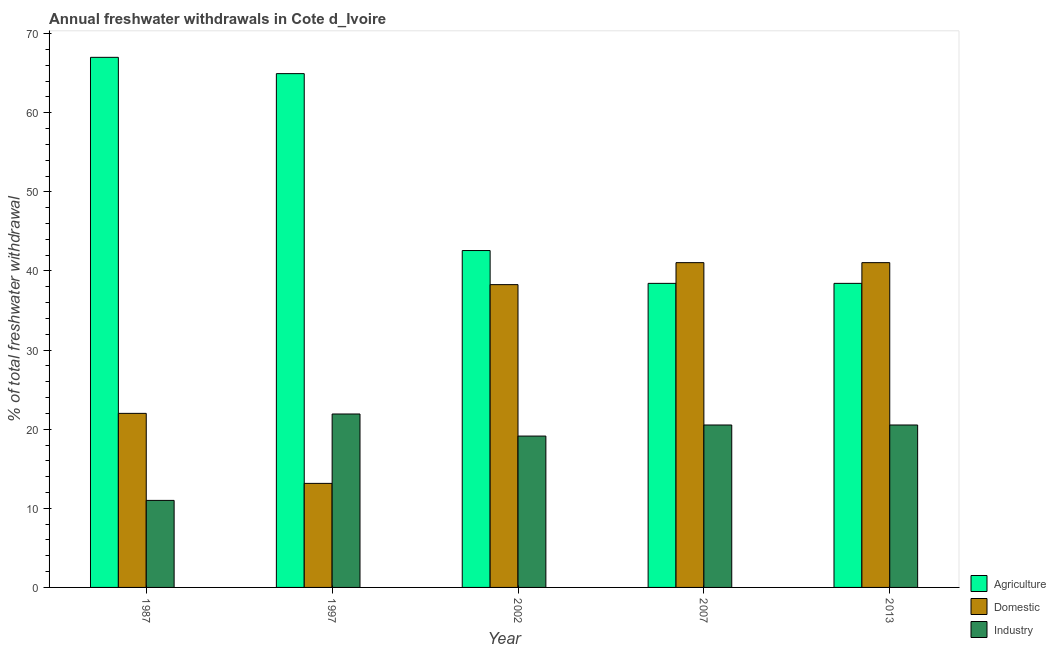How many different coloured bars are there?
Your answer should be compact. 3. Are the number of bars on each tick of the X-axis equal?
Offer a terse response. Yes. In how many cases, is the number of bars for a given year not equal to the number of legend labels?
Your response must be concise. 0. What is the percentage of freshwater withdrawal for agriculture in 1987?
Make the answer very short. 67. Across all years, what is the maximum percentage of freshwater withdrawal for domestic purposes?
Give a very brief answer. 41.05. Across all years, what is the minimum percentage of freshwater withdrawal for industry?
Your response must be concise. 11. In which year was the percentage of freshwater withdrawal for domestic purposes minimum?
Give a very brief answer. 1997. What is the total percentage of freshwater withdrawal for industry in the graph?
Provide a short and direct response. 93.11. What is the difference between the percentage of freshwater withdrawal for domestic purposes in 1997 and that in 2002?
Your response must be concise. -25.12. What is the difference between the percentage of freshwater withdrawal for domestic purposes in 2013 and the percentage of freshwater withdrawal for industry in 1997?
Your answer should be very brief. 27.9. What is the average percentage of freshwater withdrawal for industry per year?
Offer a very short reply. 18.62. In the year 2013, what is the difference between the percentage of freshwater withdrawal for agriculture and percentage of freshwater withdrawal for industry?
Provide a succinct answer. 0. In how many years, is the percentage of freshwater withdrawal for domestic purposes greater than 36 %?
Your answer should be compact. 3. What is the ratio of the percentage of freshwater withdrawal for industry in 1987 to that in 2013?
Keep it short and to the point. 0.54. What is the difference between the highest and the second highest percentage of freshwater withdrawal for agriculture?
Offer a very short reply. 2.06. What is the difference between the highest and the lowest percentage of freshwater withdrawal for domestic purposes?
Your answer should be very brief. 27.9. What does the 3rd bar from the left in 1997 represents?
Provide a succinct answer. Industry. What does the 2nd bar from the right in 1997 represents?
Ensure brevity in your answer.  Domestic. Is it the case that in every year, the sum of the percentage of freshwater withdrawal for agriculture and percentage of freshwater withdrawal for domestic purposes is greater than the percentage of freshwater withdrawal for industry?
Offer a very short reply. Yes. How many bars are there?
Your response must be concise. 15. Does the graph contain grids?
Make the answer very short. No. How many legend labels are there?
Offer a very short reply. 3. How are the legend labels stacked?
Provide a short and direct response. Vertical. What is the title of the graph?
Offer a terse response. Annual freshwater withdrawals in Cote d_Ivoire. Does "Travel services" appear as one of the legend labels in the graph?
Provide a short and direct response. No. What is the label or title of the X-axis?
Your answer should be compact. Year. What is the label or title of the Y-axis?
Your answer should be very brief. % of total freshwater withdrawal. What is the % of total freshwater withdrawal in Domestic in 1987?
Provide a short and direct response. 22. What is the % of total freshwater withdrawal of Agriculture in 1997?
Your answer should be compact. 64.94. What is the % of total freshwater withdrawal in Domestic in 1997?
Provide a succinct answer. 13.15. What is the % of total freshwater withdrawal in Industry in 1997?
Provide a short and direct response. 21.92. What is the % of total freshwater withdrawal in Agriculture in 2002?
Provide a short and direct response. 42.58. What is the % of total freshwater withdrawal in Domestic in 2002?
Keep it short and to the point. 38.27. What is the % of total freshwater withdrawal in Industry in 2002?
Your answer should be compact. 19.13. What is the % of total freshwater withdrawal of Agriculture in 2007?
Offer a very short reply. 38.43. What is the % of total freshwater withdrawal of Domestic in 2007?
Offer a terse response. 41.05. What is the % of total freshwater withdrawal of Industry in 2007?
Offer a very short reply. 20.53. What is the % of total freshwater withdrawal in Agriculture in 2013?
Offer a very short reply. 38.43. What is the % of total freshwater withdrawal of Domestic in 2013?
Offer a terse response. 41.05. What is the % of total freshwater withdrawal of Industry in 2013?
Make the answer very short. 20.53. Across all years, what is the maximum % of total freshwater withdrawal in Domestic?
Offer a very short reply. 41.05. Across all years, what is the maximum % of total freshwater withdrawal in Industry?
Ensure brevity in your answer.  21.92. Across all years, what is the minimum % of total freshwater withdrawal in Agriculture?
Give a very brief answer. 38.43. Across all years, what is the minimum % of total freshwater withdrawal in Domestic?
Make the answer very short. 13.15. What is the total % of total freshwater withdrawal of Agriculture in the graph?
Offer a terse response. 251.38. What is the total % of total freshwater withdrawal of Domestic in the graph?
Make the answer very short. 155.52. What is the total % of total freshwater withdrawal in Industry in the graph?
Make the answer very short. 93.11. What is the difference between the % of total freshwater withdrawal of Agriculture in 1987 and that in 1997?
Keep it short and to the point. 2.06. What is the difference between the % of total freshwater withdrawal in Domestic in 1987 and that in 1997?
Your response must be concise. 8.85. What is the difference between the % of total freshwater withdrawal in Industry in 1987 and that in 1997?
Your answer should be very brief. -10.92. What is the difference between the % of total freshwater withdrawal of Agriculture in 1987 and that in 2002?
Offer a terse response. 24.42. What is the difference between the % of total freshwater withdrawal in Domestic in 1987 and that in 2002?
Offer a very short reply. -16.27. What is the difference between the % of total freshwater withdrawal in Industry in 1987 and that in 2002?
Provide a succinct answer. -8.13. What is the difference between the % of total freshwater withdrawal of Agriculture in 1987 and that in 2007?
Ensure brevity in your answer.  28.57. What is the difference between the % of total freshwater withdrawal in Domestic in 1987 and that in 2007?
Your answer should be very brief. -19.05. What is the difference between the % of total freshwater withdrawal of Industry in 1987 and that in 2007?
Your answer should be very brief. -9.53. What is the difference between the % of total freshwater withdrawal of Agriculture in 1987 and that in 2013?
Offer a terse response. 28.57. What is the difference between the % of total freshwater withdrawal of Domestic in 1987 and that in 2013?
Make the answer very short. -19.05. What is the difference between the % of total freshwater withdrawal in Industry in 1987 and that in 2013?
Provide a succinct answer. -9.53. What is the difference between the % of total freshwater withdrawal of Agriculture in 1997 and that in 2002?
Your response must be concise. 22.36. What is the difference between the % of total freshwater withdrawal of Domestic in 1997 and that in 2002?
Keep it short and to the point. -25.12. What is the difference between the % of total freshwater withdrawal of Industry in 1997 and that in 2002?
Ensure brevity in your answer.  2.79. What is the difference between the % of total freshwater withdrawal in Agriculture in 1997 and that in 2007?
Make the answer very short. 26.51. What is the difference between the % of total freshwater withdrawal in Domestic in 1997 and that in 2007?
Offer a terse response. -27.9. What is the difference between the % of total freshwater withdrawal in Industry in 1997 and that in 2007?
Keep it short and to the point. 1.39. What is the difference between the % of total freshwater withdrawal of Agriculture in 1997 and that in 2013?
Provide a succinct answer. 26.51. What is the difference between the % of total freshwater withdrawal in Domestic in 1997 and that in 2013?
Provide a short and direct response. -27.9. What is the difference between the % of total freshwater withdrawal of Industry in 1997 and that in 2013?
Give a very brief answer. 1.39. What is the difference between the % of total freshwater withdrawal of Agriculture in 2002 and that in 2007?
Provide a succinct answer. 4.15. What is the difference between the % of total freshwater withdrawal of Domestic in 2002 and that in 2007?
Offer a terse response. -2.78. What is the difference between the % of total freshwater withdrawal in Industry in 2002 and that in 2007?
Offer a very short reply. -1.4. What is the difference between the % of total freshwater withdrawal of Agriculture in 2002 and that in 2013?
Ensure brevity in your answer.  4.15. What is the difference between the % of total freshwater withdrawal in Domestic in 2002 and that in 2013?
Ensure brevity in your answer.  -2.78. What is the difference between the % of total freshwater withdrawal of Agriculture in 2007 and that in 2013?
Your response must be concise. 0. What is the difference between the % of total freshwater withdrawal in Agriculture in 1987 and the % of total freshwater withdrawal in Domestic in 1997?
Give a very brief answer. 53.85. What is the difference between the % of total freshwater withdrawal of Agriculture in 1987 and the % of total freshwater withdrawal of Industry in 1997?
Provide a succinct answer. 45.08. What is the difference between the % of total freshwater withdrawal in Domestic in 1987 and the % of total freshwater withdrawal in Industry in 1997?
Provide a succinct answer. 0.08. What is the difference between the % of total freshwater withdrawal in Agriculture in 1987 and the % of total freshwater withdrawal in Domestic in 2002?
Your response must be concise. 28.73. What is the difference between the % of total freshwater withdrawal of Agriculture in 1987 and the % of total freshwater withdrawal of Industry in 2002?
Your answer should be very brief. 47.87. What is the difference between the % of total freshwater withdrawal in Domestic in 1987 and the % of total freshwater withdrawal in Industry in 2002?
Offer a terse response. 2.87. What is the difference between the % of total freshwater withdrawal in Agriculture in 1987 and the % of total freshwater withdrawal in Domestic in 2007?
Your answer should be compact. 25.95. What is the difference between the % of total freshwater withdrawal in Agriculture in 1987 and the % of total freshwater withdrawal in Industry in 2007?
Ensure brevity in your answer.  46.47. What is the difference between the % of total freshwater withdrawal of Domestic in 1987 and the % of total freshwater withdrawal of Industry in 2007?
Offer a very short reply. 1.47. What is the difference between the % of total freshwater withdrawal in Agriculture in 1987 and the % of total freshwater withdrawal in Domestic in 2013?
Provide a succinct answer. 25.95. What is the difference between the % of total freshwater withdrawal in Agriculture in 1987 and the % of total freshwater withdrawal in Industry in 2013?
Offer a very short reply. 46.47. What is the difference between the % of total freshwater withdrawal in Domestic in 1987 and the % of total freshwater withdrawal in Industry in 2013?
Keep it short and to the point. 1.47. What is the difference between the % of total freshwater withdrawal in Agriculture in 1997 and the % of total freshwater withdrawal in Domestic in 2002?
Your response must be concise. 26.67. What is the difference between the % of total freshwater withdrawal of Agriculture in 1997 and the % of total freshwater withdrawal of Industry in 2002?
Provide a short and direct response. 45.81. What is the difference between the % of total freshwater withdrawal in Domestic in 1997 and the % of total freshwater withdrawal in Industry in 2002?
Your answer should be very brief. -5.98. What is the difference between the % of total freshwater withdrawal of Agriculture in 1997 and the % of total freshwater withdrawal of Domestic in 2007?
Your response must be concise. 23.89. What is the difference between the % of total freshwater withdrawal of Agriculture in 1997 and the % of total freshwater withdrawal of Industry in 2007?
Your answer should be compact. 44.41. What is the difference between the % of total freshwater withdrawal of Domestic in 1997 and the % of total freshwater withdrawal of Industry in 2007?
Ensure brevity in your answer.  -7.38. What is the difference between the % of total freshwater withdrawal in Agriculture in 1997 and the % of total freshwater withdrawal in Domestic in 2013?
Offer a terse response. 23.89. What is the difference between the % of total freshwater withdrawal of Agriculture in 1997 and the % of total freshwater withdrawal of Industry in 2013?
Your answer should be compact. 44.41. What is the difference between the % of total freshwater withdrawal of Domestic in 1997 and the % of total freshwater withdrawal of Industry in 2013?
Your response must be concise. -7.38. What is the difference between the % of total freshwater withdrawal of Agriculture in 2002 and the % of total freshwater withdrawal of Domestic in 2007?
Offer a terse response. 1.53. What is the difference between the % of total freshwater withdrawal in Agriculture in 2002 and the % of total freshwater withdrawal in Industry in 2007?
Make the answer very short. 22.05. What is the difference between the % of total freshwater withdrawal in Domestic in 2002 and the % of total freshwater withdrawal in Industry in 2007?
Your answer should be very brief. 17.74. What is the difference between the % of total freshwater withdrawal of Agriculture in 2002 and the % of total freshwater withdrawal of Domestic in 2013?
Offer a very short reply. 1.53. What is the difference between the % of total freshwater withdrawal of Agriculture in 2002 and the % of total freshwater withdrawal of Industry in 2013?
Ensure brevity in your answer.  22.05. What is the difference between the % of total freshwater withdrawal of Domestic in 2002 and the % of total freshwater withdrawal of Industry in 2013?
Your response must be concise. 17.74. What is the difference between the % of total freshwater withdrawal of Agriculture in 2007 and the % of total freshwater withdrawal of Domestic in 2013?
Your answer should be very brief. -2.62. What is the difference between the % of total freshwater withdrawal in Domestic in 2007 and the % of total freshwater withdrawal in Industry in 2013?
Your answer should be compact. 20.52. What is the average % of total freshwater withdrawal in Agriculture per year?
Your answer should be compact. 50.28. What is the average % of total freshwater withdrawal of Domestic per year?
Give a very brief answer. 31.1. What is the average % of total freshwater withdrawal of Industry per year?
Give a very brief answer. 18.62. In the year 1987, what is the difference between the % of total freshwater withdrawal of Agriculture and % of total freshwater withdrawal of Domestic?
Your answer should be compact. 45. In the year 1987, what is the difference between the % of total freshwater withdrawal in Agriculture and % of total freshwater withdrawal in Industry?
Your answer should be compact. 56. In the year 1987, what is the difference between the % of total freshwater withdrawal in Domestic and % of total freshwater withdrawal in Industry?
Provide a short and direct response. 11. In the year 1997, what is the difference between the % of total freshwater withdrawal in Agriculture and % of total freshwater withdrawal in Domestic?
Your answer should be very brief. 51.79. In the year 1997, what is the difference between the % of total freshwater withdrawal in Agriculture and % of total freshwater withdrawal in Industry?
Offer a very short reply. 43.02. In the year 1997, what is the difference between the % of total freshwater withdrawal of Domestic and % of total freshwater withdrawal of Industry?
Keep it short and to the point. -8.77. In the year 2002, what is the difference between the % of total freshwater withdrawal in Agriculture and % of total freshwater withdrawal in Domestic?
Provide a short and direct response. 4.31. In the year 2002, what is the difference between the % of total freshwater withdrawal in Agriculture and % of total freshwater withdrawal in Industry?
Your response must be concise. 23.45. In the year 2002, what is the difference between the % of total freshwater withdrawal in Domestic and % of total freshwater withdrawal in Industry?
Provide a short and direct response. 19.14. In the year 2007, what is the difference between the % of total freshwater withdrawal of Agriculture and % of total freshwater withdrawal of Domestic?
Give a very brief answer. -2.62. In the year 2007, what is the difference between the % of total freshwater withdrawal of Domestic and % of total freshwater withdrawal of Industry?
Make the answer very short. 20.52. In the year 2013, what is the difference between the % of total freshwater withdrawal in Agriculture and % of total freshwater withdrawal in Domestic?
Offer a very short reply. -2.62. In the year 2013, what is the difference between the % of total freshwater withdrawal in Domestic and % of total freshwater withdrawal in Industry?
Give a very brief answer. 20.52. What is the ratio of the % of total freshwater withdrawal of Agriculture in 1987 to that in 1997?
Your answer should be compact. 1.03. What is the ratio of the % of total freshwater withdrawal of Domestic in 1987 to that in 1997?
Your answer should be compact. 1.67. What is the ratio of the % of total freshwater withdrawal in Industry in 1987 to that in 1997?
Your answer should be compact. 0.5. What is the ratio of the % of total freshwater withdrawal in Agriculture in 1987 to that in 2002?
Provide a short and direct response. 1.57. What is the ratio of the % of total freshwater withdrawal in Domestic in 1987 to that in 2002?
Offer a terse response. 0.57. What is the ratio of the % of total freshwater withdrawal in Industry in 1987 to that in 2002?
Give a very brief answer. 0.57. What is the ratio of the % of total freshwater withdrawal of Agriculture in 1987 to that in 2007?
Provide a short and direct response. 1.74. What is the ratio of the % of total freshwater withdrawal in Domestic in 1987 to that in 2007?
Your response must be concise. 0.54. What is the ratio of the % of total freshwater withdrawal of Industry in 1987 to that in 2007?
Make the answer very short. 0.54. What is the ratio of the % of total freshwater withdrawal in Agriculture in 1987 to that in 2013?
Your answer should be compact. 1.74. What is the ratio of the % of total freshwater withdrawal in Domestic in 1987 to that in 2013?
Your answer should be compact. 0.54. What is the ratio of the % of total freshwater withdrawal in Industry in 1987 to that in 2013?
Your response must be concise. 0.54. What is the ratio of the % of total freshwater withdrawal of Agriculture in 1997 to that in 2002?
Keep it short and to the point. 1.53. What is the ratio of the % of total freshwater withdrawal of Domestic in 1997 to that in 2002?
Your answer should be very brief. 0.34. What is the ratio of the % of total freshwater withdrawal of Industry in 1997 to that in 2002?
Give a very brief answer. 1.15. What is the ratio of the % of total freshwater withdrawal in Agriculture in 1997 to that in 2007?
Offer a very short reply. 1.69. What is the ratio of the % of total freshwater withdrawal in Domestic in 1997 to that in 2007?
Provide a succinct answer. 0.32. What is the ratio of the % of total freshwater withdrawal in Industry in 1997 to that in 2007?
Your answer should be compact. 1.07. What is the ratio of the % of total freshwater withdrawal in Agriculture in 1997 to that in 2013?
Provide a succinct answer. 1.69. What is the ratio of the % of total freshwater withdrawal of Domestic in 1997 to that in 2013?
Your answer should be very brief. 0.32. What is the ratio of the % of total freshwater withdrawal in Industry in 1997 to that in 2013?
Your answer should be very brief. 1.07. What is the ratio of the % of total freshwater withdrawal in Agriculture in 2002 to that in 2007?
Provide a short and direct response. 1.11. What is the ratio of the % of total freshwater withdrawal of Domestic in 2002 to that in 2007?
Provide a short and direct response. 0.93. What is the ratio of the % of total freshwater withdrawal of Industry in 2002 to that in 2007?
Ensure brevity in your answer.  0.93. What is the ratio of the % of total freshwater withdrawal of Agriculture in 2002 to that in 2013?
Offer a terse response. 1.11. What is the ratio of the % of total freshwater withdrawal of Domestic in 2002 to that in 2013?
Offer a terse response. 0.93. What is the ratio of the % of total freshwater withdrawal in Industry in 2002 to that in 2013?
Your answer should be compact. 0.93. What is the ratio of the % of total freshwater withdrawal in Agriculture in 2007 to that in 2013?
Your answer should be very brief. 1. What is the difference between the highest and the second highest % of total freshwater withdrawal in Agriculture?
Ensure brevity in your answer.  2.06. What is the difference between the highest and the second highest % of total freshwater withdrawal of Industry?
Ensure brevity in your answer.  1.39. What is the difference between the highest and the lowest % of total freshwater withdrawal of Agriculture?
Ensure brevity in your answer.  28.57. What is the difference between the highest and the lowest % of total freshwater withdrawal in Domestic?
Offer a very short reply. 27.9. What is the difference between the highest and the lowest % of total freshwater withdrawal of Industry?
Offer a terse response. 10.92. 